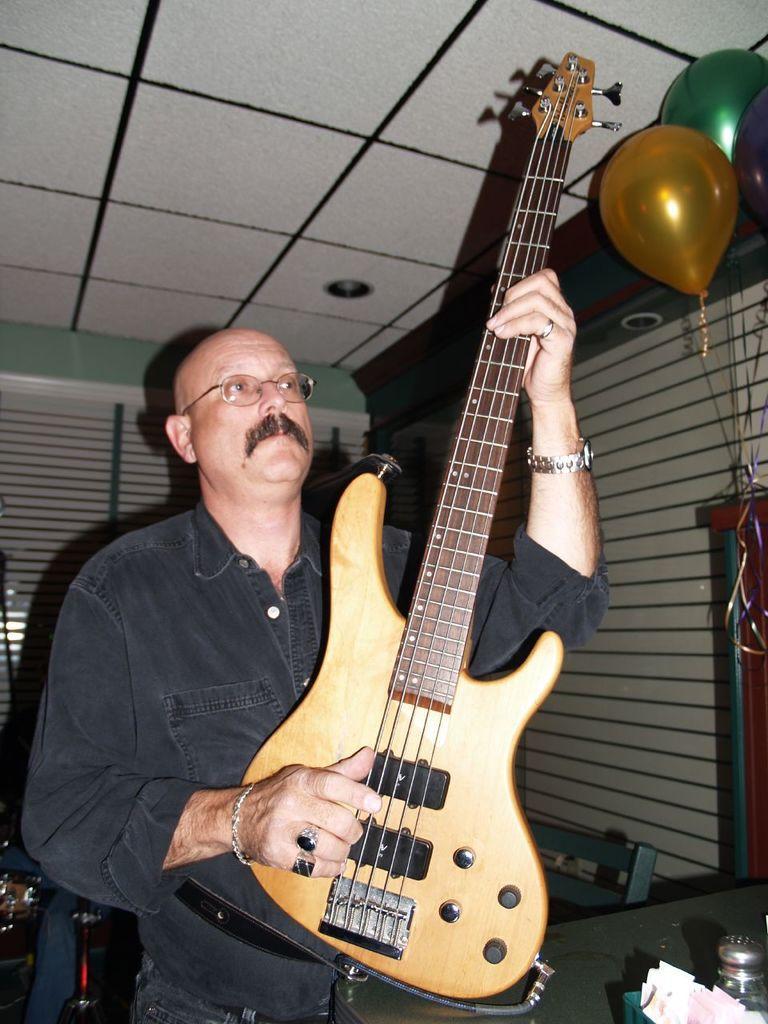How would you summarize this image in a sentence or two? It is a a party ,there are three balloons to right side and there is a man who is holding a guitar in his hands ,in the background there is a window ,there is also a table and chair right side to the man. 